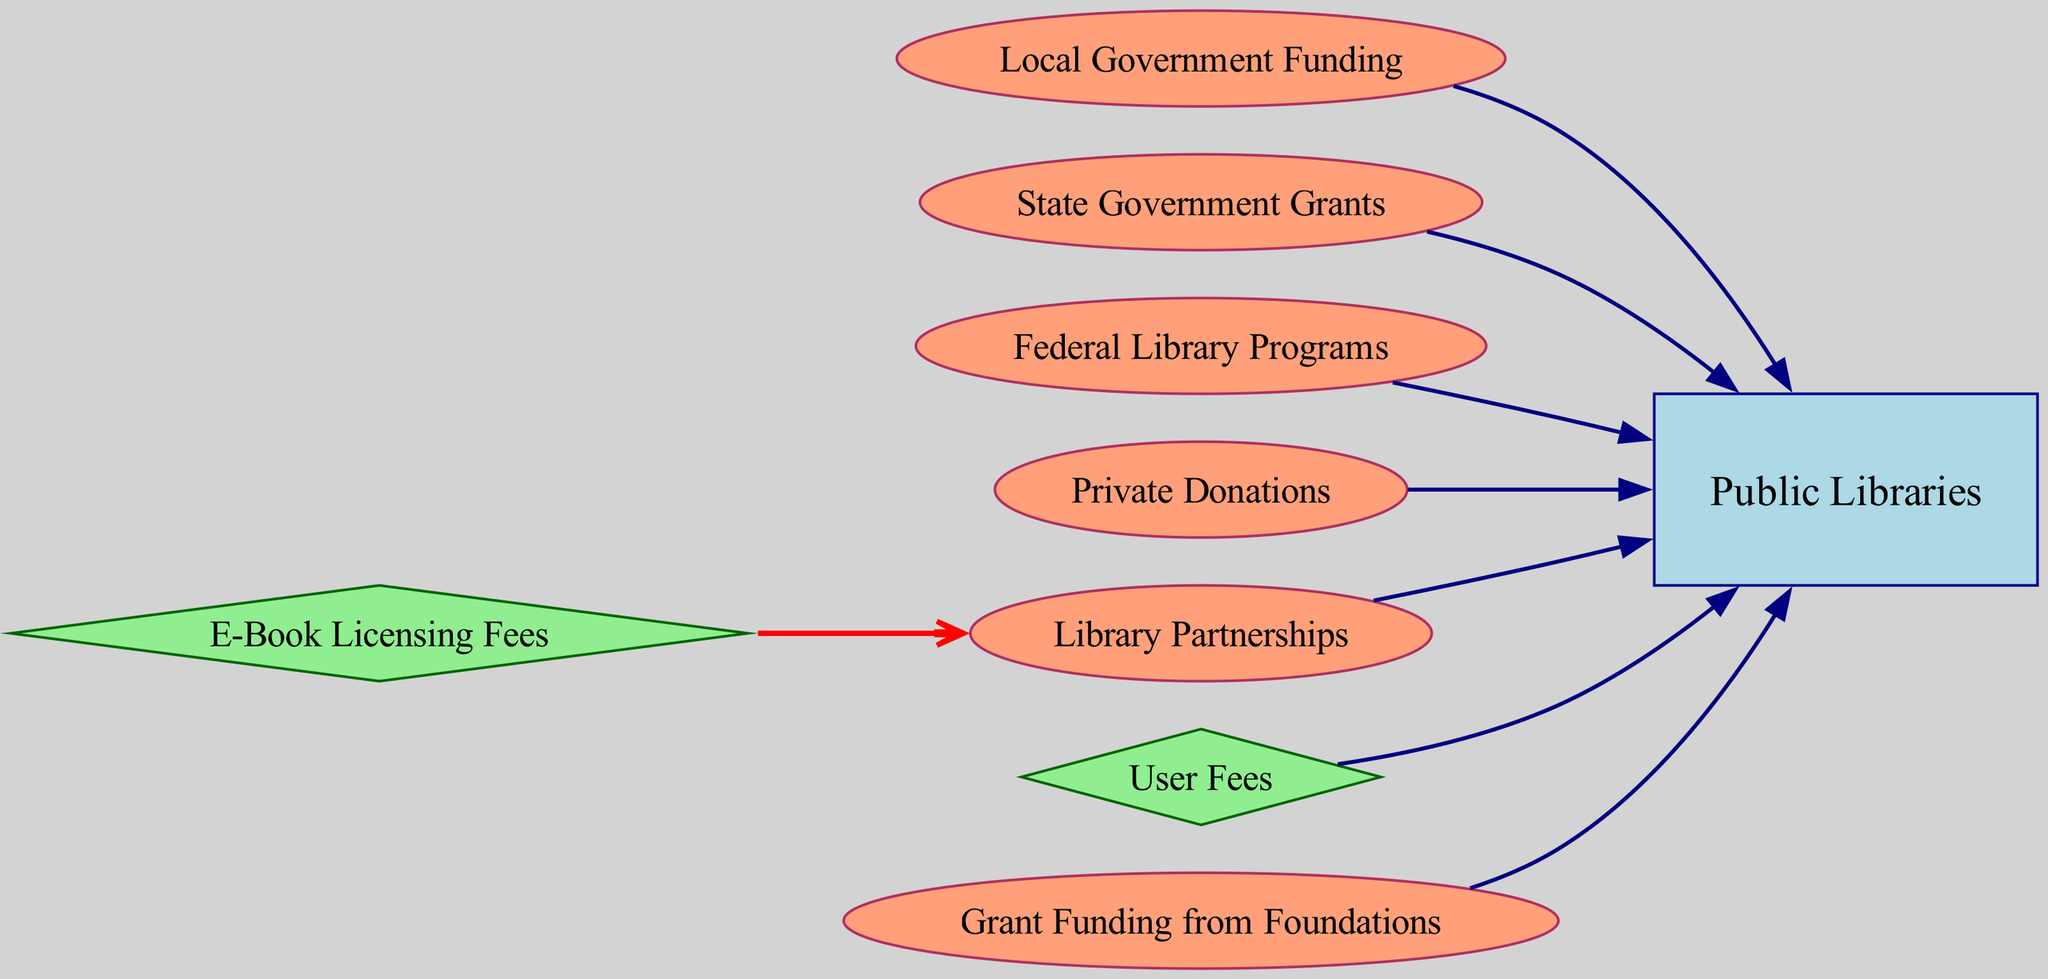What are the sources of funding for public libraries? The diagram lists several sources of funding which includes Local Government Funding, State Government Grants, Federal Library Programs, Private Donations, Library Partnerships, User Fees, E-Book Licensing Fees, and Grant Funding from Foundations.
Answer: Local Government Funding, State Government Grants, Federal Library Programs, Private Donations, Library Partnerships, User Fees, E-Book Licensing Fees, Grant Funding from Foundations How many nodes are present in the diagram? By counting the nodes listed in the data, there are a total of eight nodes representing various entities related to library funding.
Answer: Eight nodes Which funding source leads to Library Partnerships? The diagram shows that E-Book Licensing Fees lead to Library Partnerships as indicated by the directed edge connecting these two nodes.
Answer: E-Book Licensing Fees How many edges point towards Public Libraries? There are six edges pointing towards Public Libraries from Local Government Funding, State Government Grants, Federal Library Programs, Private Donations, Library Partnerships, User Fees, and Grant Funding from Foundations.
Answer: Six edges What type of funding is represented by a diamond shape in the diagram? The nodes represented as diamonds are fees associated with library services, which include User Fees and E-Book Licensing Fees, indicating their special significance as funding mechanisms requiring specific payments.
Answer: User Fees, E-Book Licensing Fees What color are the edges leading to Public Libraries? The edges leading to Public Libraries are colored navy, indicating a common funding source that is distinct from the one leading from E-Book Licensing Fees.
Answer: Navy Between which nodes does the edge have a red color? The red edge represents a unique connection from E-Book Licensing Fees to Library Partnerships, which highlights the significance of digital content licensing in the funding landscape.
Answer: E-Book Licensing Fees and Library Partnerships What funding source allows for partnerships aimed at public library funding? Library Partnerships represent a connection point for various funding sources to enhance public library initiatives and services, showcasing collaborative efforts as crucial in the digital landscape.
Answer: Library Partnerships 